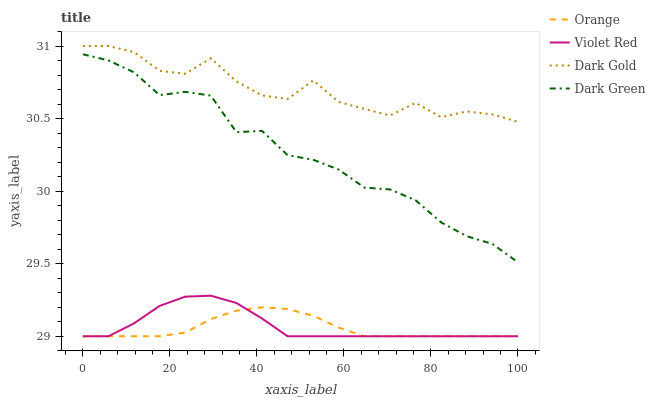Does Orange have the minimum area under the curve?
Answer yes or no. Yes. Does Dark Gold have the maximum area under the curve?
Answer yes or no. Yes. Does Violet Red have the minimum area under the curve?
Answer yes or no. No. Does Violet Red have the maximum area under the curve?
Answer yes or no. No. Is Orange the smoothest?
Answer yes or no. Yes. Is Dark Gold the roughest?
Answer yes or no. Yes. Is Violet Red the smoothest?
Answer yes or no. No. Is Violet Red the roughest?
Answer yes or no. No. Does Dark Green have the lowest value?
Answer yes or no. No. Does Violet Red have the highest value?
Answer yes or no. No. Is Violet Red less than Dark Gold?
Answer yes or no. Yes. Is Dark Gold greater than Orange?
Answer yes or no. Yes. Does Violet Red intersect Dark Gold?
Answer yes or no. No. 